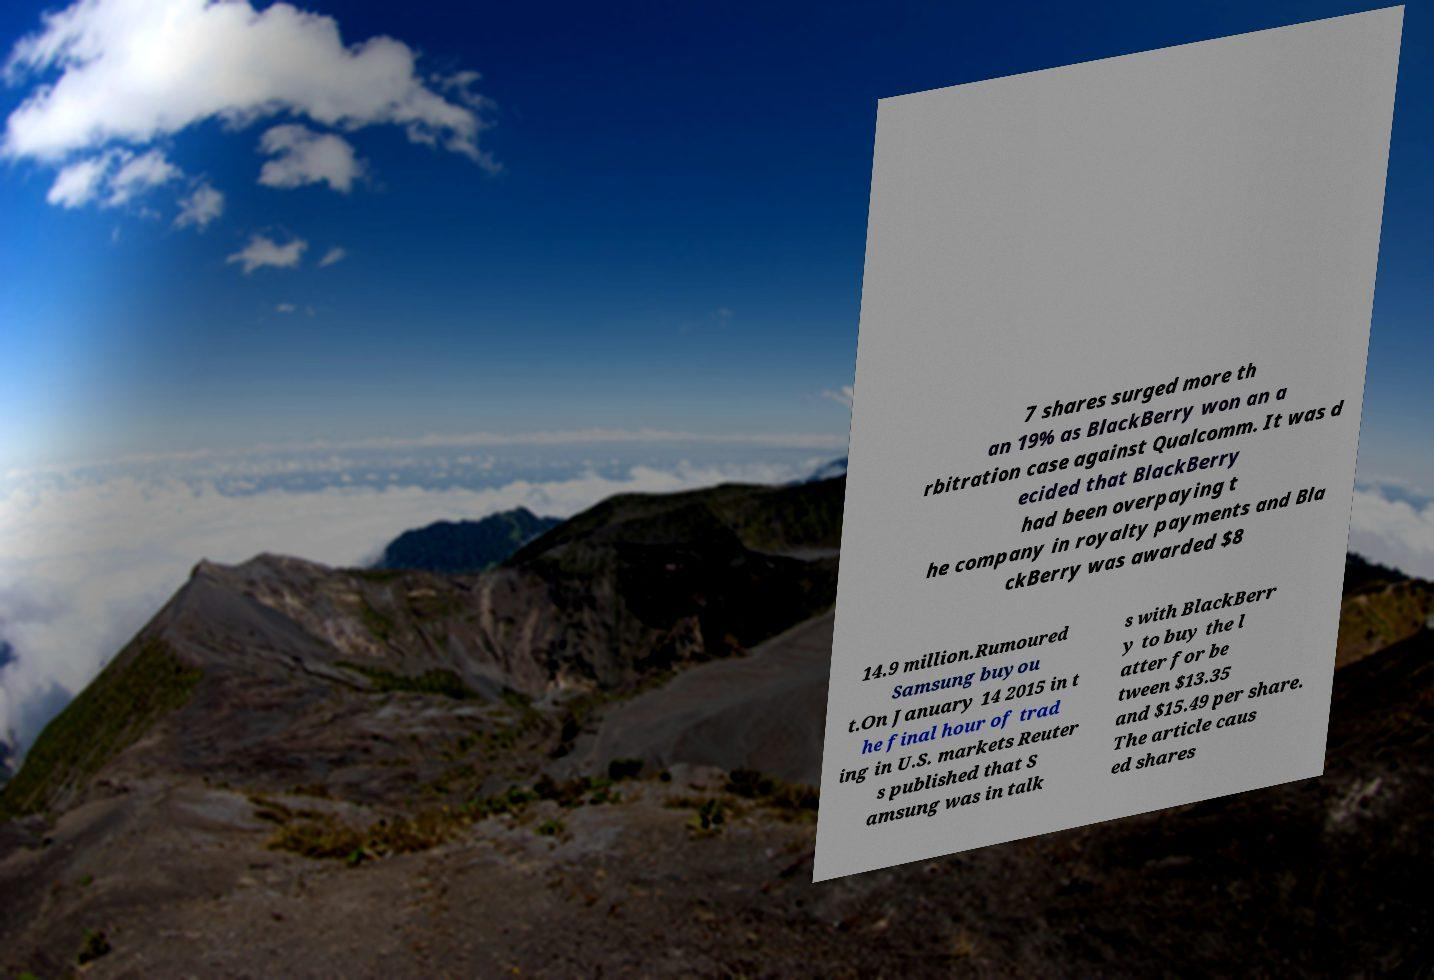Please identify and transcribe the text found in this image. 7 shares surged more th an 19% as BlackBerry won an a rbitration case against Qualcomm. It was d ecided that BlackBerry had been overpaying t he company in royalty payments and Bla ckBerry was awarded $8 14.9 million.Rumoured Samsung buyou t.On January 14 2015 in t he final hour of trad ing in U.S. markets Reuter s published that S amsung was in talk s with BlackBerr y to buy the l atter for be tween $13.35 and $15.49 per share. The article caus ed shares 